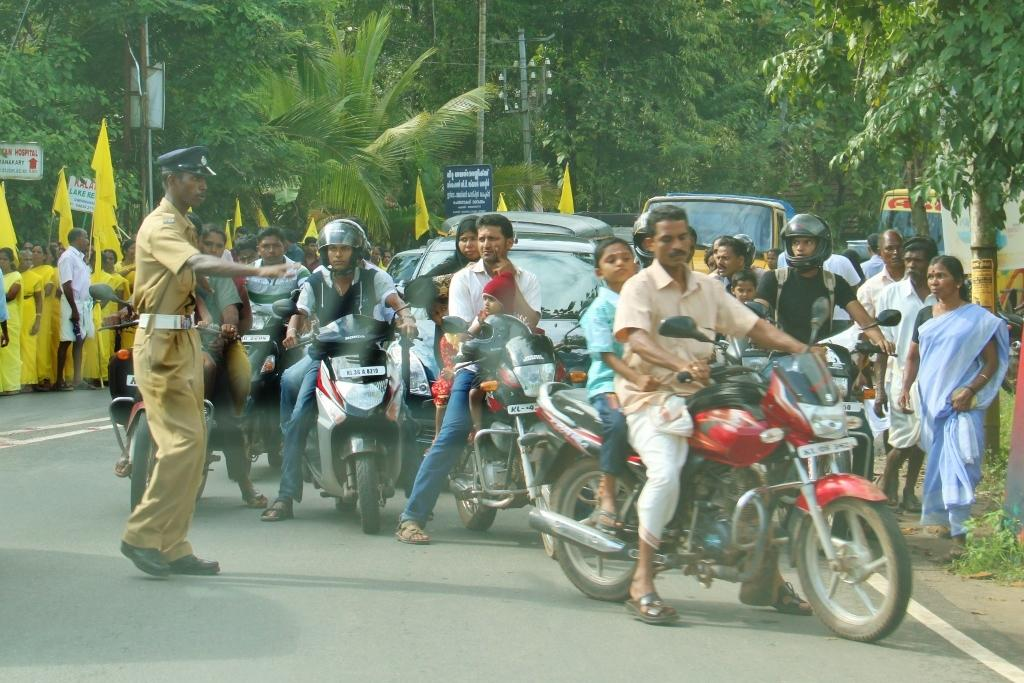What are the persons in the image doing? The persons in the image are riding bikes on the road. Can you describe the background of the image? There is a man standing in the background, and there is a tree visible in the image. What objects can be seen in the image besides the persons riding bikes? There is a pole, a flag, and a vehicle in the image. Can you tell me how many kitties are playing in the air in the image? There are no kitties present in the image, and they are not playing in the air. What type of step can be seen leading up to the vehicle? There is no step visible in the image. 